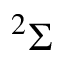Convert formula to latex. <formula><loc_0><loc_0><loc_500><loc_500>^ { 2 } \Sigma</formula> 